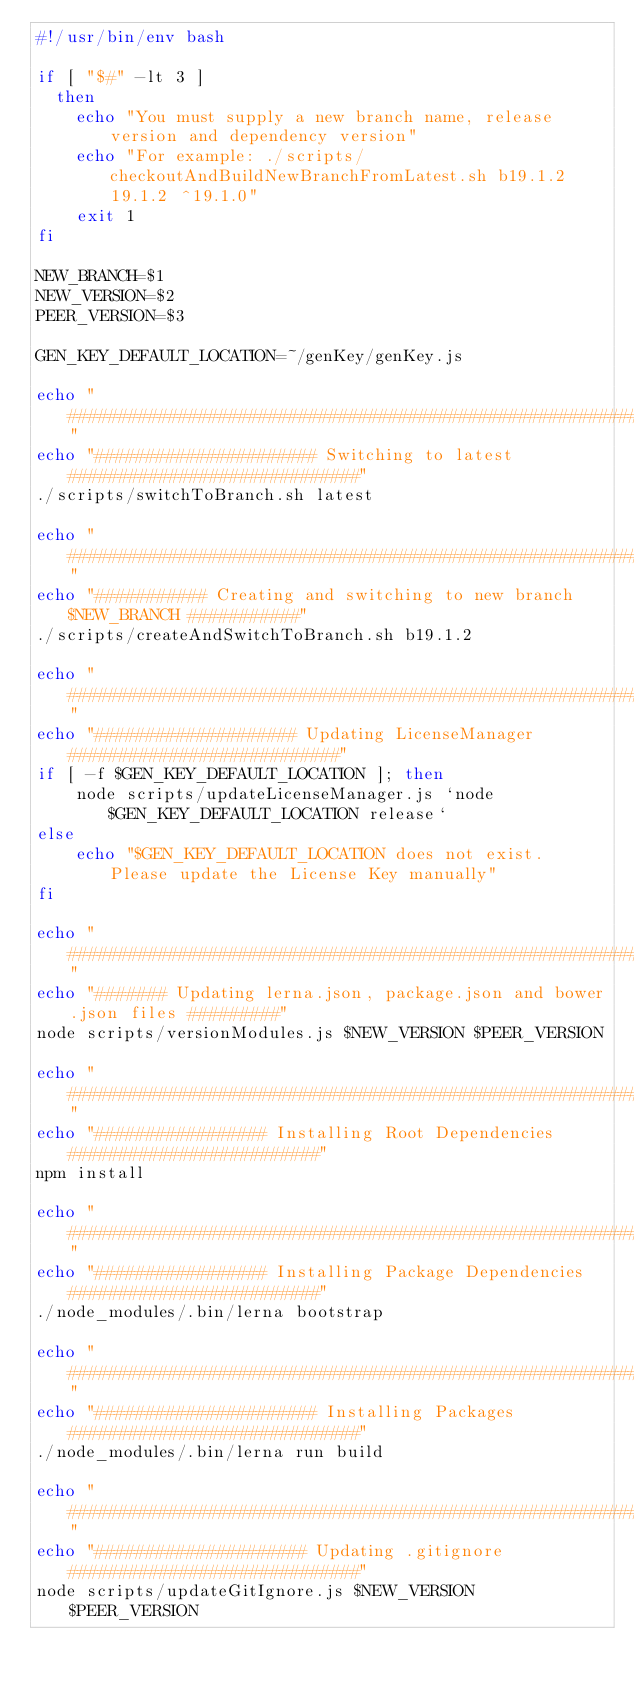<code> <loc_0><loc_0><loc_500><loc_500><_Bash_>#!/usr/bin/env bash

if [ "$#" -lt 3 ]
  then
    echo "You must supply a new branch name, release version and dependency version"
    echo "For example: ./scripts/checkoutAndBuildNewBranchFromLatest.sh b19.1.2 19.1.2 ^19.1.0"
    exit 1
fi

NEW_BRANCH=$1
NEW_VERSION=$2
PEER_VERSION=$3

GEN_KEY_DEFAULT_LOCATION=~/genKey/genKey.js

echo "########################################################################"
echo "###################### Switching to latest #############################"
./scripts/switchToBranch.sh latest

echo "########################################################################"
echo "########### Creating and switching to new branch $NEW_BRANCH ###########"
./scripts/createAndSwitchToBranch.sh b19.1.2

echo "########################################################################"
echo "#################### Updating LicenseManager ###########################"
if [ -f $GEN_KEY_DEFAULT_LOCATION ]; then
    node scripts/updateLicenseManager.js `node $GEN_KEY_DEFAULT_LOCATION release`
else
    echo "$GEN_KEY_DEFAULT_LOCATION does not exist. Please update the License Key manually"
fi

echo "########################################################################"
echo "####### Updating lerna.json, package.json and bower.json files #########"
node scripts/versionModules.js $NEW_VERSION $PEER_VERSION

echo "########################################################################"
echo "################# Installing Root Dependencies #########################"
npm install

echo "########################################################################"
echo "################# Installing Package Dependencies #########################"
./node_modules/.bin/lerna bootstrap

echo "########################################################################"
echo "###################### Installing Packages #############################"
./node_modules/.bin/lerna run build

echo "########################################################################"
echo "##################### Updating .gitignore #############################"
node scripts/updateGitIgnore.js $NEW_VERSION $PEER_VERSION

</code> 